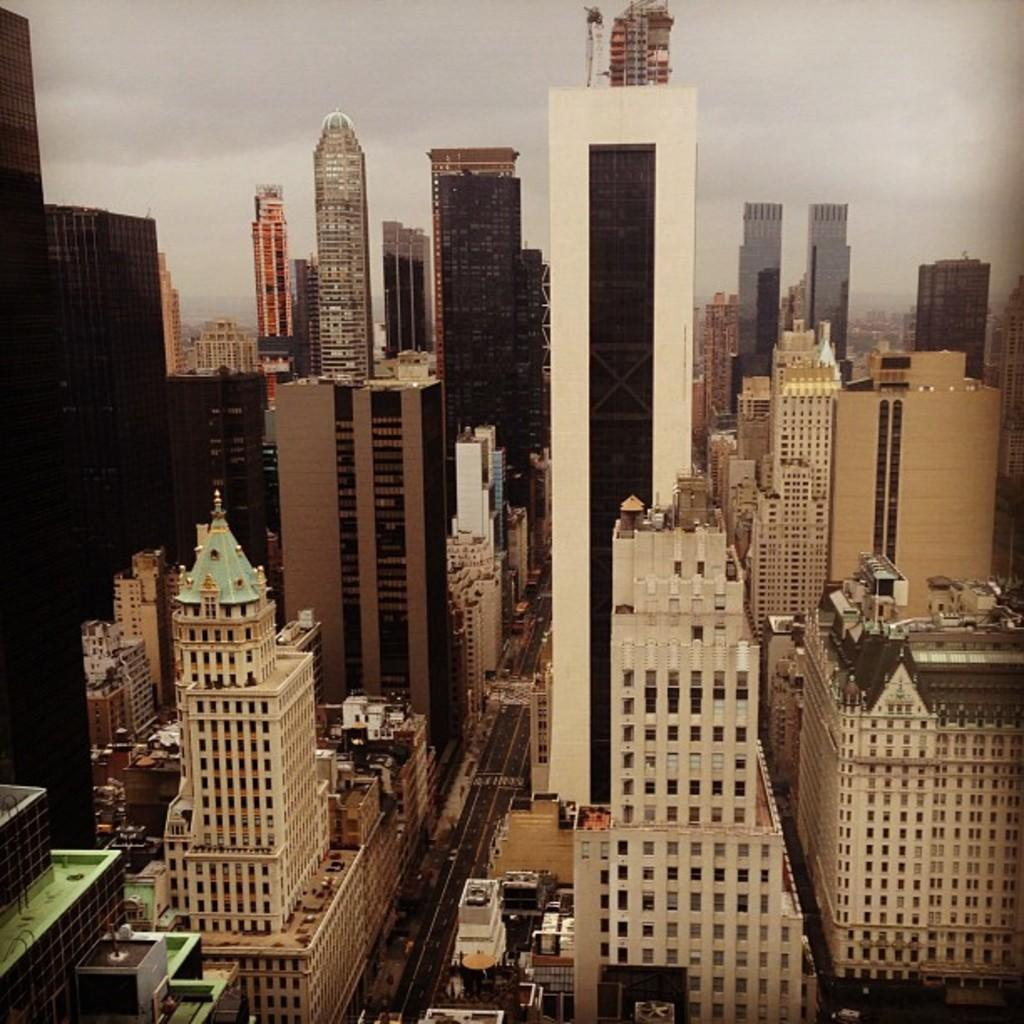What type of structures can be seen in the image? There are many buildings and towers in the image. What is the condition of the sky in the image? The sky is cloudy in the image. Are there any vehicles visible in the image? Yes, there are vehicles visible on the road in the image. How many dimes are scattered on the ground in the image? There are no dimes visible on the ground in the image. What type of match is being played in the middle of the image? There is no match being played in the image; it features buildings, towers, a cloudy sky, and vehicles on the road. 